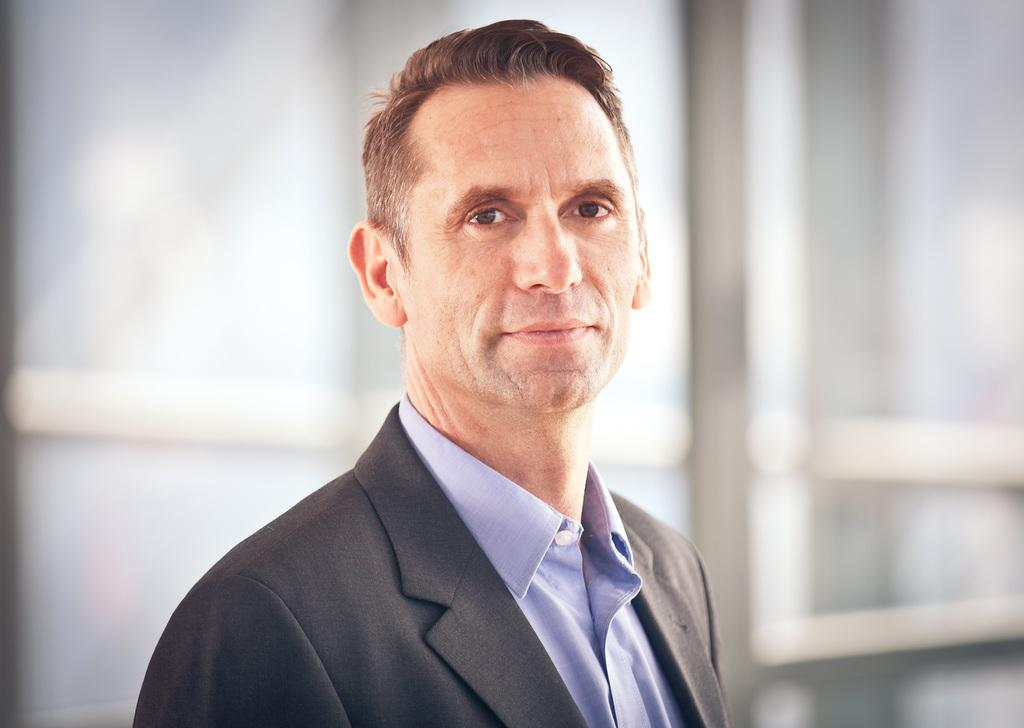What is the group of people in the image doing? The group of people in the image is sitting on the ground. Are there any objects or structures nearby? The provided facts do not mention any objects or structures nearby. How many pages does the book the dog is reading have in the image? There is no book or dog present in the image; it features a group of people sitting on the ground. 